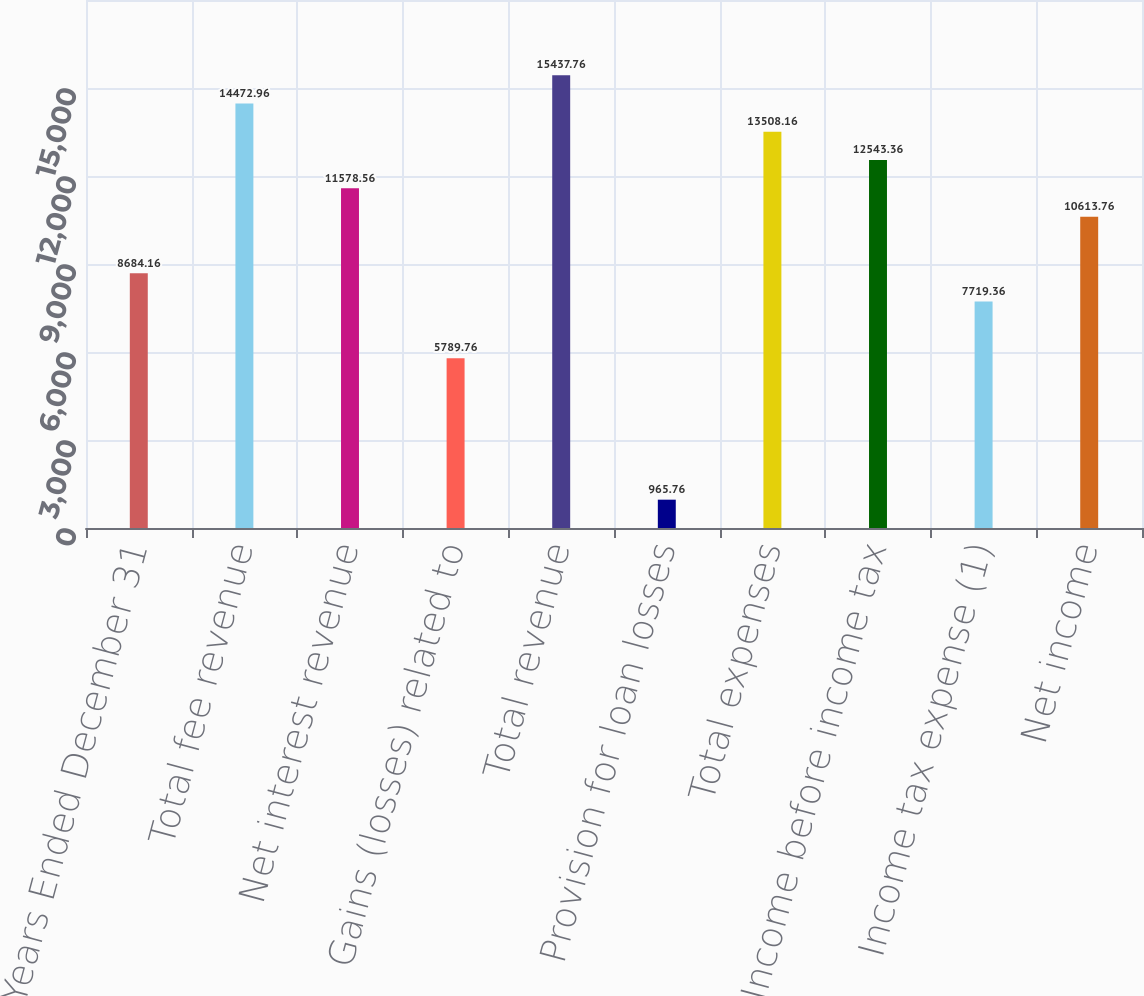<chart> <loc_0><loc_0><loc_500><loc_500><bar_chart><fcel>Years Ended December 31<fcel>Total fee revenue<fcel>Net interest revenue<fcel>Gains (losses) related to<fcel>Total revenue<fcel>Provision for loan losses<fcel>Total expenses<fcel>Income before income tax<fcel>Income tax expense (1)<fcel>Net income<nl><fcel>8684.16<fcel>14473<fcel>11578.6<fcel>5789.76<fcel>15437.8<fcel>965.76<fcel>13508.2<fcel>12543.4<fcel>7719.36<fcel>10613.8<nl></chart> 